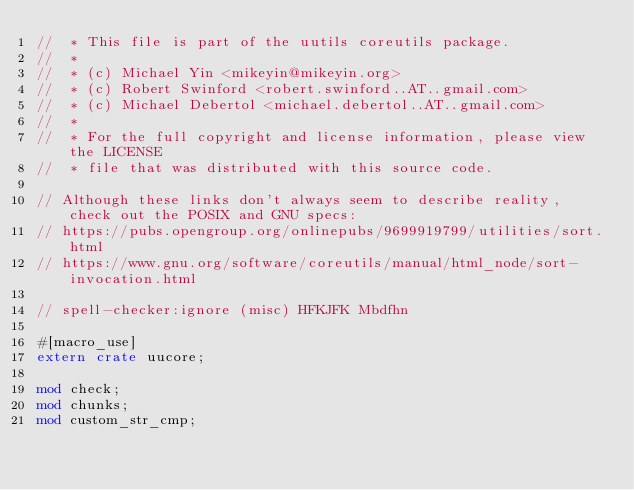Convert code to text. <code><loc_0><loc_0><loc_500><loc_500><_Rust_>//  * This file is part of the uutils coreutils package.
//  *
//  * (c) Michael Yin <mikeyin@mikeyin.org>
//  * (c) Robert Swinford <robert.swinford..AT..gmail.com>
//  * (c) Michael Debertol <michael.debertol..AT..gmail.com>
//  *
//  * For the full copyright and license information, please view the LICENSE
//  * file that was distributed with this source code.

// Although these links don't always seem to describe reality, check out the POSIX and GNU specs:
// https://pubs.opengroup.org/onlinepubs/9699919799/utilities/sort.html
// https://www.gnu.org/software/coreutils/manual/html_node/sort-invocation.html

// spell-checker:ignore (misc) HFKJFK Mbdfhn

#[macro_use]
extern crate uucore;

mod check;
mod chunks;
mod custom_str_cmp;</code> 